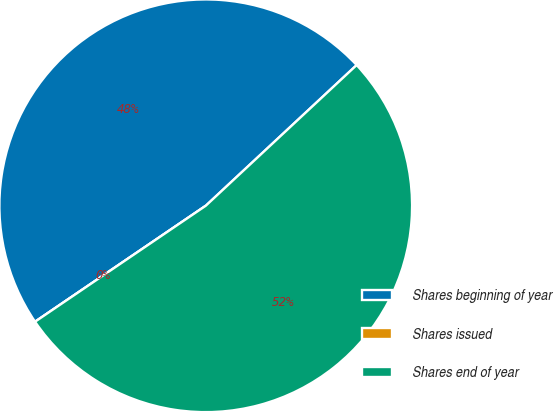<chart> <loc_0><loc_0><loc_500><loc_500><pie_chart><fcel>Shares beginning of year<fcel>Shares issued<fcel>Shares end of year<nl><fcel>47.55%<fcel>0.0%<fcel>52.44%<nl></chart> 